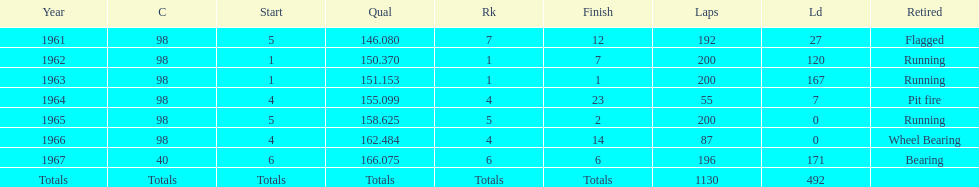What is the most usual cause for a retired vehicle? Running. 